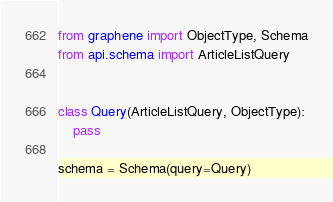Convert code to text. <code><loc_0><loc_0><loc_500><loc_500><_Python_>from graphene import ObjectType, Schema
from api.schema import ArticleListQuery


class Query(ArticleListQuery, ObjectType):
    pass

schema = Schema(query=Query)
</code> 